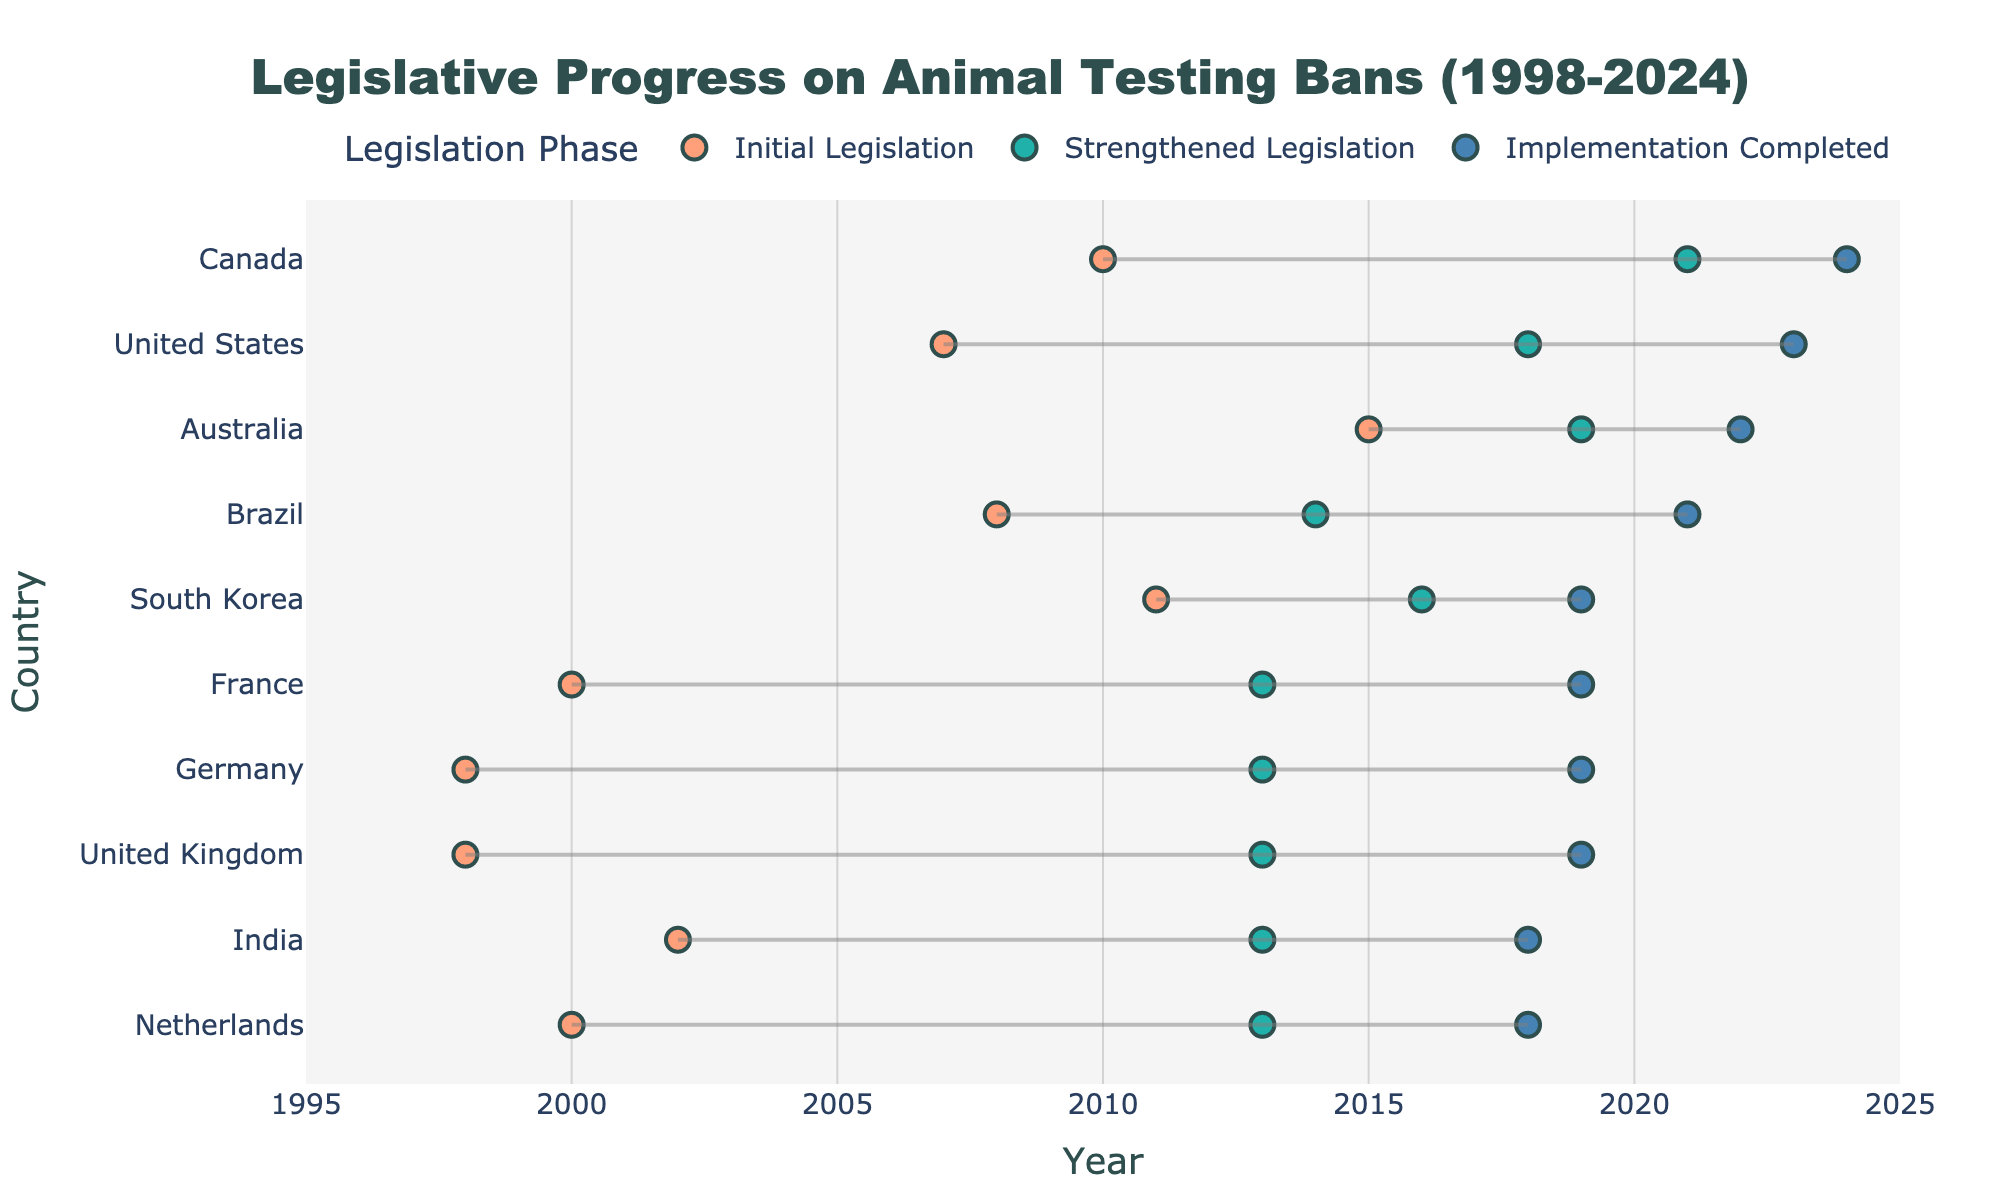What is the title of the figure? The title is prominently displayed at the top of the figure.
Answer: Legislative Progress on Animal Testing Bans (1998-2024) Which country completed the implementation of animal testing bans most recently? The latest data point on the x-axis indicates the most recent completion year, 2024, which is listed next to Canada.
Answer: Canada How many regions are represented in the data? Reviewing the unique regions under the "Region" data section yields five regions: Europe, North America, Asia, Oceania, and South America.
Answer: Five What years are shown for South Korea's legislative progress? The dots for South Korea are connected by lines on the plot, and the hover information gives the specific years for each legislative phase.
Answer: Initial: 2011, Strengthened: 2016, Completed: 2019 Which country initiated legislation in 2015? By checking the x-axis and the countries associated with dots in 2015, we see that Australia initiated their legislation in that year.
Answer: Australia How long did it take for the United States to complete the implementation after the initial legislation? Subtract the year of the initial legislation (2007) from the year of implementation completion (2023). The difference is 2023 - 2007 = 16 years.
Answer: 16 years Which countries had their initial and strengthened legislation phases in the same year? Compare the initial and strengthened legislation years for each country. Germany, United Kingdom, France, and Netherlands show both phases in the year 2013.
Answer: Germany, United Kingdom, France, Netherlands Compare the time taken to complete implementation for India and Australia. Which one took longer? India's timeline is 2002 (initial) to 2018 (completed), a duration of 16 years. Australia's timeline is 2015 (initial) to 2022 (completed), a duration of 7 years. Therefore, India took longer.
Answer: India What is the average year of 'Implementation Completed' for the countries in Europe? The years of "Implementation Completed" for European countries (UK, Germany, France, Netherlands) are 2019, 2019, 2019, and 2018. The average year is (2019 + 2019 + 2019 + 2018)/4 = 2018.75, rounded to the nearest year is 2019.
Answer: 2019 